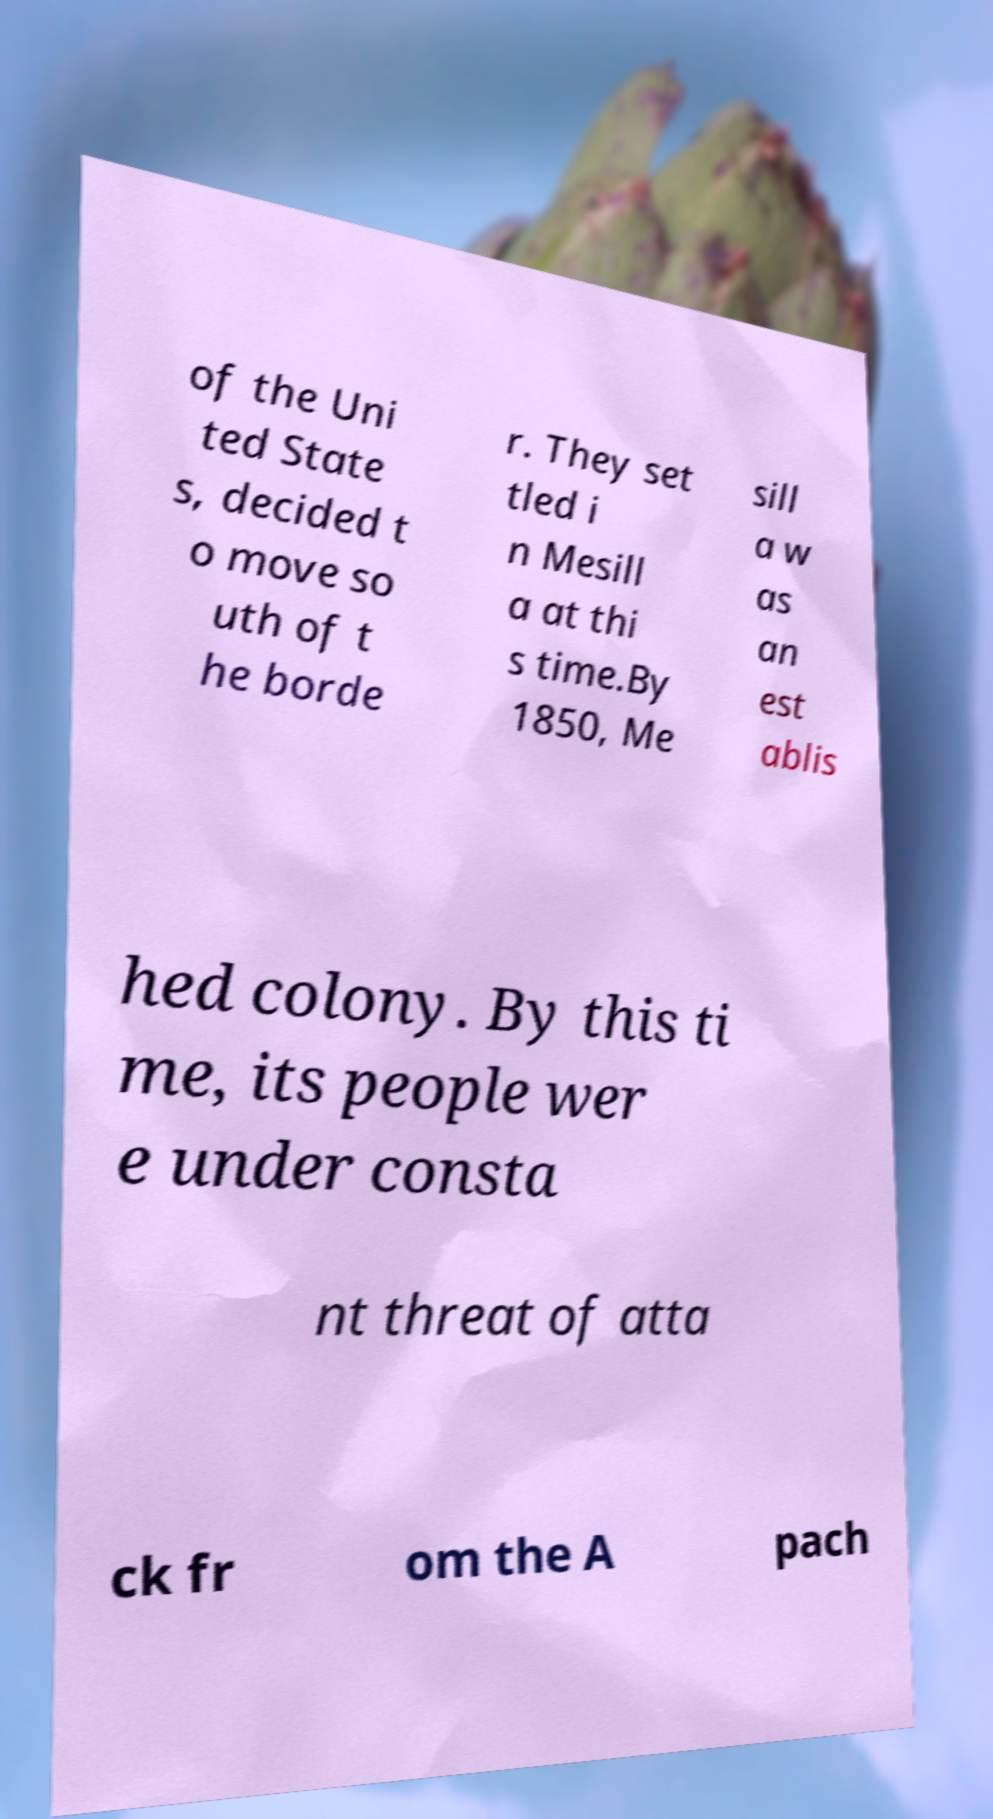Please identify and transcribe the text found in this image. of the Uni ted State s, decided t o move so uth of t he borde r. They set tled i n Mesill a at thi s time.By 1850, Me sill a w as an est ablis hed colony. By this ti me, its people wer e under consta nt threat of atta ck fr om the A pach 